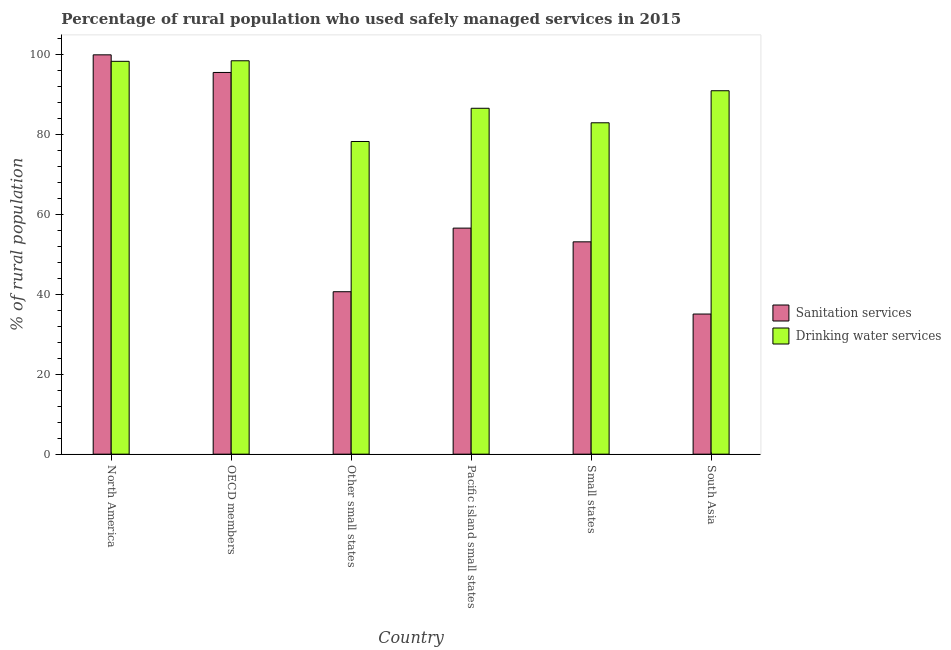How many groups of bars are there?
Offer a very short reply. 6. How many bars are there on the 6th tick from the left?
Keep it short and to the point. 2. How many bars are there on the 5th tick from the right?
Provide a succinct answer. 2. What is the label of the 3rd group of bars from the left?
Your answer should be very brief. Other small states. In how many cases, is the number of bars for a given country not equal to the number of legend labels?
Give a very brief answer. 0. What is the percentage of rural population who used drinking water services in Small states?
Your response must be concise. 82.9. Across all countries, what is the maximum percentage of rural population who used sanitation services?
Make the answer very short. 99.9. Across all countries, what is the minimum percentage of rural population who used drinking water services?
Your response must be concise. 78.22. In which country was the percentage of rural population who used sanitation services maximum?
Give a very brief answer. North America. What is the total percentage of rural population who used drinking water services in the graph?
Provide a succinct answer. 535.27. What is the difference between the percentage of rural population who used sanitation services in OECD members and that in Small states?
Ensure brevity in your answer.  42.38. What is the difference between the percentage of rural population who used drinking water services in Small states and the percentage of rural population who used sanitation services in OECD members?
Your answer should be very brief. -12.59. What is the average percentage of rural population who used sanitation services per country?
Your answer should be compact. 63.46. What is the difference between the percentage of rural population who used sanitation services and percentage of rural population who used drinking water services in Other small states?
Your response must be concise. -37.59. What is the ratio of the percentage of rural population who used sanitation services in Other small states to that in Pacific island small states?
Give a very brief answer. 0.72. Is the difference between the percentage of rural population who used sanitation services in Other small states and Small states greater than the difference between the percentage of rural population who used drinking water services in Other small states and Small states?
Offer a terse response. No. What is the difference between the highest and the second highest percentage of rural population who used sanitation services?
Provide a short and direct response. 4.41. What is the difference between the highest and the lowest percentage of rural population who used drinking water services?
Offer a terse response. 20.19. In how many countries, is the percentage of rural population who used sanitation services greater than the average percentage of rural population who used sanitation services taken over all countries?
Make the answer very short. 2. Is the sum of the percentage of rural population who used sanitation services in OECD members and South Asia greater than the maximum percentage of rural population who used drinking water services across all countries?
Keep it short and to the point. Yes. What does the 2nd bar from the left in Pacific island small states represents?
Provide a succinct answer. Drinking water services. What does the 1st bar from the right in Other small states represents?
Your answer should be compact. Drinking water services. How many bars are there?
Give a very brief answer. 12. Are all the bars in the graph horizontal?
Offer a terse response. No. How many countries are there in the graph?
Keep it short and to the point. 6. What is the difference between two consecutive major ticks on the Y-axis?
Make the answer very short. 20. Does the graph contain any zero values?
Offer a very short reply. No. How many legend labels are there?
Ensure brevity in your answer.  2. How are the legend labels stacked?
Provide a short and direct response. Vertical. What is the title of the graph?
Provide a succinct answer. Percentage of rural population who used safely managed services in 2015. Does "Forest land" appear as one of the legend labels in the graph?
Give a very brief answer. No. What is the label or title of the X-axis?
Your answer should be compact. Country. What is the label or title of the Y-axis?
Offer a very short reply. % of rural population. What is the % of rural population of Sanitation services in North America?
Your answer should be very brief. 99.9. What is the % of rural population in Drinking water services in North America?
Make the answer very short. 98.28. What is the % of rural population of Sanitation services in OECD members?
Offer a very short reply. 95.49. What is the % of rural population of Drinking water services in OECD members?
Provide a succinct answer. 98.42. What is the % of rural population in Sanitation services in Other small states?
Give a very brief answer. 40.64. What is the % of rural population in Drinking water services in Other small states?
Keep it short and to the point. 78.22. What is the % of rural population of Sanitation services in Pacific island small states?
Give a very brief answer. 56.55. What is the % of rural population in Drinking water services in Pacific island small states?
Your answer should be very brief. 86.53. What is the % of rural population in Sanitation services in Small states?
Your answer should be compact. 53.12. What is the % of rural population in Drinking water services in Small states?
Offer a very short reply. 82.9. What is the % of rural population in Sanitation services in South Asia?
Keep it short and to the point. 35.05. What is the % of rural population of Drinking water services in South Asia?
Your answer should be compact. 90.92. Across all countries, what is the maximum % of rural population in Sanitation services?
Offer a very short reply. 99.9. Across all countries, what is the maximum % of rural population in Drinking water services?
Keep it short and to the point. 98.42. Across all countries, what is the minimum % of rural population in Sanitation services?
Offer a terse response. 35.05. Across all countries, what is the minimum % of rural population in Drinking water services?
Your response must be concise. 78.22. What is the total % of rural population of Sanitation services in the graph?
Offer a terse response. 380.76. What is the total % of rural population in Drinking water services in the graph?
Your response must be concise. 535.27. What is the difference between the % of rural population of Sanitation services in North America and that in OECD members?
Your answer should be compact. 4.41. What is the difference between the % of rural population in Drinking water services in North America and that in OECD members?
Offer a very short reply. -0.14. What is the difference between the % of rural population in Sanitation services in North America and that in Other small states?
Give a very brief answer. 59.26. What is the difference between the % of rural population of Drinking water services in North America and that in Other small states?
Make the answer very short. 20.06. What is the difference between the % of rural population of Sanitation services in North America and that in Pacific island small states?
Your response must be concise. 43.35. What is the difference between the % of rural population of Drinking water services in North America and that in Pacific island small states?
Offer a terse response. 11.75. What is the difference between the % of rural population of Sanitation services in North America and that in Small states?
Provide a short and direct response. 46.78. What is the difference between the % of rural population in Drinking water services in North America and that in Small states?
Offer a terse response. 15.38. What is the difference between the % of rural population in Sanitation services in North America and that in South Asia?
Your answer should be compact. 64.85. What is the difference between the % of rural population in Drinking water services in North America and that in South Asia?
Provide a succinct answer. 7.36. What is the difference between the % of rural population of Sanitation services in OECD members and that in Other small states?
Keep it short and to the point. 54.86. What is the difference between the % of rural population of Drinking water services in OECD members and that in Other small states?
Provide a succinct answer. 20.19. What is the difference between the % of rural population of Sanitation services in OECD members and that in Pacific island small states?
Make the answer very short. 38.94. What is the difference between the % of rural population in Drinking water services in OECD members and that in Pacific island small states?
Make the answer very short. 11.88. What is the difference between the % of rural population of Sanitation services in OECD members and that in Small states?
Make the answer very short. 42.38. What is the difference between the % of rural population in Drinking water services in OECD members and that in Small states?
Keep it short and to the point. 15.51. What is the difference between the % of rural population in Sanitation services in OECD members and that in South Asia?
Keep it short and to the point. 60.44. What is the difference between the % of rural population of Drinking water services in OECD members and that in South Asia?
Keep it short and to the point. 7.5. What is the difference between the % of rural population of Sanitation services in Other small states and that in Pacific island small states?
Give a very brief answer. -15.92. What is the difference between the % of rural population in Drinking water services in Other small states and that in Pacific island small states?
Ensure brevity in your answer.  -8.31. What is the difference between the % of rural population in Sanitation services in Other small states and that in Small states?
Offer a very short reply. -12.48. What is the difference between the % of rural population in Drinking water services in Other small states and that in Small states?
Give a very brief answer. -4.68. What is the difference between the % of rural population of Sanitation services in Other small states and that in South Asia?
Provide a short and direct response. 5.58. What is the difference between the % of rural population in Drinking water services in Other small states and that in South Asia?
Provide a succinct answer. -12.69. What is the difference between the % of rural population in Sanitation services in Pacific island small states and that in Small states?
Your response must be concise. 3.43. What is the difference between the % of rural population in Drinking water services in Pacific island small states and that in Small states?
Offer a very short reply. 3.63. What is the difference between the % of rural population in Sanitation services in Pacific island small states and that in South Asia?
Ensure brevity in your answer.  21.5. What is the difference between the % of rural population of Drinking water services in Pacific island small states and that in South Asia?
Your answer should be very brief. -4.38. What is the difference between the % of rural population in Sanitation services in Small states and that in South Asia?
Provide a succinct answer. 18.06. What is the difference between the % of rural population in Drinking water services in Small states and that in South Asia?
Your answer should be compact. -8.01. What is the difference between the % of rural population in Sanitation services in North America and the % of rural population in Drinking water services in OECD members?
Ensure brevity in your answer.  1.48. What is the difference between the % of rural population in Sanitation services in North America and the % of rural population in Drinking water services in Other small states?
Make the answer very short. 21.68. What is the difference between the % of rural population in Sanitation services in North America and the % of rural population in Drinking water services in Pacific island small states?
Your answer should be compact. 13.37. What is the difference between the % of rural population of Sanitation services in North America and the % of rural population of Drinking water services in Small states?
Offer a very short reply. 17. What is the difference between the % of rural population in Sanitation services in North America and the % of rural population in Drinking water services in South Asia?
Provide a short and direct response. 8.98. What is the difference between the % of rural population of Sanitation services in OECD members and the % of rural population of Drinking water services in Other small states?
Provide a short and direct response. 17.27. What is the difference between the % of rural population of Sanitation services in OECD members and the % of rural population of Drinking water services in Pacific island small states?
Offer a terse response. 8.96. What is the difference between the % of rural population in Sanitation services in OECD members and the % of rural population in Drinking water services in Small states?
Provide a short and direct response. 12.59. What is the difference between the % of rural population of Sanitation services in OECD members and the % of rural population of Drinking water services in South Asia?
Provide a short and direct response. 4.58. What is the difference between the % of rural population in Sanitation services in Other small states and the % of rural population in Drinking water services in Pacific island small states?
Provide a short and direct response. -45.9. What is the difference between the % of rural population in Sanitation services in Other small states and the % of rural population in Drinking water services in Small states?
Your answer should be compact. -42.27. What is the difference between the % of rural population in Sanitation services in Other small states and the % of rural population in Drinking water services in South Asia?
Provide a succinct answer. -50.28. What is the difference between the % of rural population in Sanitation services in Pacific island small states and the % of rural population in Drinking water services in Small states?
Keep it short and to the point. -26.35. What is the difference between the % of rural population of Sanitation services in Pacific island small states and the % of rural population of Drinking water services in South Asia?
Your response must be concise. -34.36. What is the difference between the % of rural population in Sanitation services in Small states and the % of rural population in Drinking water services in South Asia?
Provide a succinct answer. -37.8. What is the average % of rural population in Sanitation services per country?
Offer a terse response. 63.46. What is the average % of rural population of Drinking water services per country?
Offer a very short reply. 89.21. What is the difference between the % of rural population in Sanitation services and % of rural population in Drinking water services in North America?
Offer a very short reply. 1.62. What is the difference between the % of rural population of Sanitation services and % of rural population of Drinking water services in OECD members?
Ensure brevity in your answer.  -2.92. What is the difference between the % of rural population of Sanitation services and % of rural population of Drinking water services in Other small states?
Provide a short and direct response. -37.59. What is the difference between the % of rural population in Sanitation services and % of rural population in Drinking water services in Pacific island small states?
Make the answer very short. -29.98. What is the difference between the % of rural population of Sanitation services and % of rural population of Drinking water services in Small states?
Keep it short and to the point. -29.78. What is the difference between the % of rural population of Sanitation services and % of rural population of Drinking water services in South Asia?
Make the answer very short. -55.86. What is the ratio of the % of rural population in Sanitation services in North America to that in OECD members?
Offer a terse response. 1.05. What is the ratio of the % of rural population of Sanitation services in North America to that in Other small states?
Make the answer very short. 2.46. What is the ratio of the % of rural population of Drinking water services in North America to that in Other small states?
Your answer should be compact. 1.26. What is the ratio of the % of rural population in Sanitation services in North America to that in Pacific island small states?
Your answer should be very brief. 1.77. What is the ratio of the % of rural population in Drinking water services in North America to that in Pacific island small states?
Your response must be concise. 1.14. What is the ratio of the % of rural population of Sanitation services in North America to that in Small states?
Your answer should be very brief. 1.88. What is the ratio of the % of rural population of Drinking water services in North America to that in Small states?
Give a very brief answer. 1.19. What is the ratio of the % of rural population in Sanitation services in North America to that in South Asia?
Your answer should be very brief. 2.85. What is the ratio of the % of rural population of Drinking water services in North America to that in South Asia?
Your answer should be very brief. 1.08. What is the ratio of the % of rural population in Sanitation services in OECD members to that in Other small states?
Offer a terse response. 2.35. What is the ratio of the % of rural population in Drinking water services in OECD members to that in Other small states?
Your response must be concise. 1.26. What is the ratio of the % of rural population in Sanitation services in OECD members to that in Pacific island small states?
Your answer should be compact. 1.69. What is the ratio of the % of rural population of Drinking water services in OECD members to that in Pacific island small states?
Provide a short and direct response. 1.14. What is the ratio of the % of rural population of Sanitation services in OECD members to that in Small states?
Provide a short and direct response. 1.8. What is the ratio of the % of rural population of Drinking water services in OECD members to that in Small states?
Offer a very short reply. 1.19. What is the ratio of the % of rural population of Sanitation services in OECD members to that in South Asia?
Ensure brevity in your answer.  2.72. What is the ratio of the % of rural population of Drinking water services in OECD members to that in South Asia?
Offer a terse response. 1.08. What is the ratio of the % of rural population of Sanitation services in Other small states to that in Pacific island small states?
Make the answer very short. 0.72. What is the ratio of the % of rural population of Drinking water services in Other small states to that in Pacific island small states?
Your answer should be compact. 0.9. What is the ratio of the % of rural population in Sanitation services in Other small states to that in Small states?
Offer a very short reply. 0.77. What is the ratio of the % of rural population in Drinking water services in Other small states to that in Small states?
Your response must be concise. 0.94. What is the ratio of the % of rural population of Sanitation services in Other small states to that in South Asia?
Keep it short and to the point. 1.16. What is the ratio of the % of rural population of Drinking water services in Other small states to that in South Asia?
Provide a short and direct response. 0.86. What is the ratio of the % of rural population of Sanitation services in Pacific island small states to that in Small states?
Your answer should be compact. 1.06. What is the ratio of the % of rural population in Drinking water services in Pacific island small states to that in Small states?
Give a very brief answer. 1.04. What is the ratio of the % of rural population of Sanitation services in Pacific island small states to that in South Asia?
Ensure brevity in your answer.  1.61. What is the ratio of the % of rural population of Drinking water services in Pacific island small states to that in South Asia?
Offer a terse response. 0.95. What is the ratio of the % of rural population in Sanitation services in Small states to that in South Asia?
Offer a very short reply. 1.52. What is the ratio of the % of rural population of Drinking water services in Small states to that in South Asia?
Make the answer very short. 0.91. What is the difference between the highest and the second highest % of rural population in Sanitation services?
Give a very brief answer. 4.41. What is the difference between the highest and the second highest % of rural population in Drinking water services?
Your response must be concise. 0.14. What is the difference between the highest and the lowest % of rural population of Sanitation services?
Offer a terse response. 64.85. What is the difference between the highest and the lowest % of rural population in Drinking water services?
Offer a terse response. 20.19. 